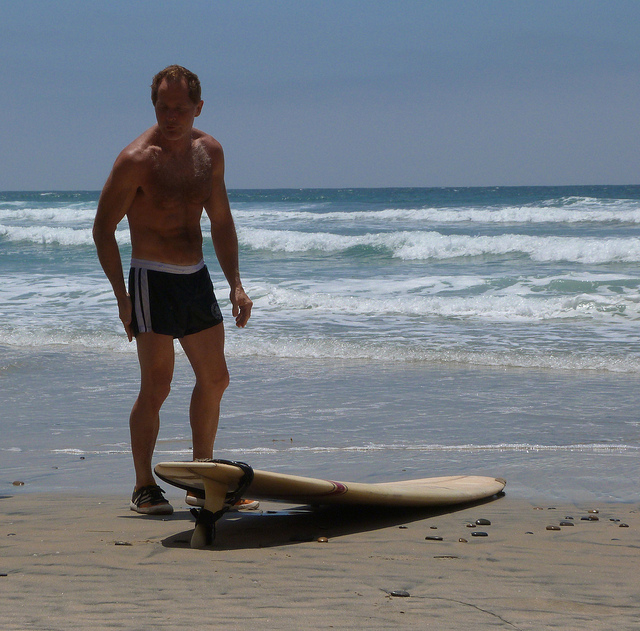How many people are visible in the image? There is only one person visible in the image, situated on the beach near the shore. 